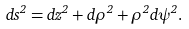<formula> <loc_0><loc_0><loc_500><loc_500>d s ^ { 2 } = d z ^ { 2 } + d \rho ^ { 2 } + \rho ^ { 2 } d \psi ^ { 2 } .</formula> 